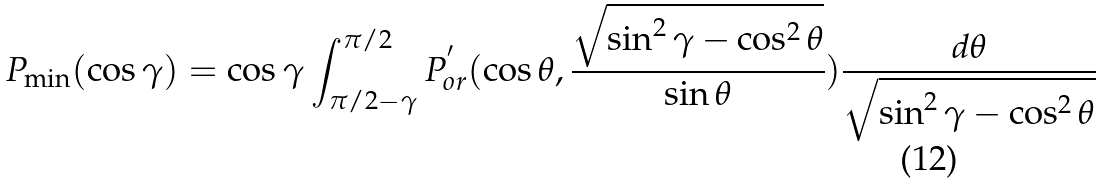<formula> <loc_0><loc_0><loc_500><loc_500>P _ { \min } ( \cos \gamma ) = \cos \gamma \int _ { \pi / 2 - \gamma } ^ { \pi / 2 } P ^ { ^ { \prime } } _ { o r } ( \cos \theta , \frac { \sqrt { \sin ^ { 2 } \gamma - \cos ^ { 2 } \theta } } { \sin \theta } ) \frac { d \theta } { \sqrt { \sin ^ { 2 } \gamma - \cos ^ { 2 } \theta } }</formula> 